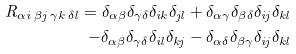Convert formula to latex. <formula><loc_0><loc_0><loc_500><loc_500>R _ { \alpha i \, \beta j \, \gamma k \, \delta l } = \delta _ { \alpha \beta } \delta _ { \gamma \delta } \delta _ { i k } \delta _ { j l } + \delta _ { \alpha \gamma } \delta _ { \beta \delta } \delta _ { i j } \delta _ { k l } \\ - \delta _ { \alpha \beta } \delta _ { \gamma \delta } \delta _ { i l } \delta _ { k j } - \delta _ { \alpha \delta } \delta _ { \beta \gamma } \delta _ { i j } \delta _ { k l }</formula> 